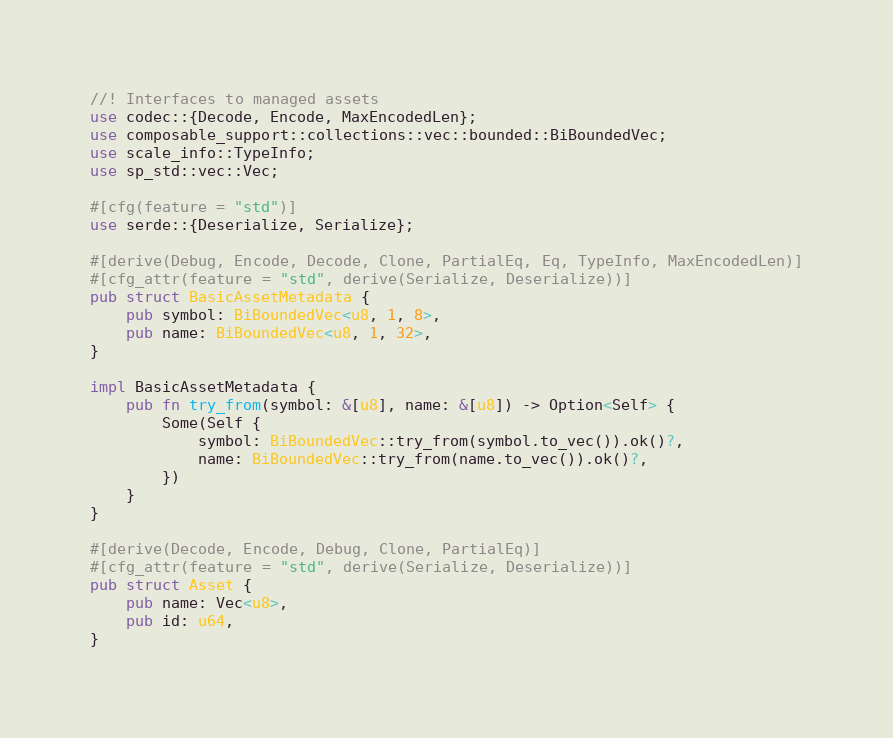Convert code to text. <code><loc_0><loc_0><loc_500><loc_500><_Rust_>//! Interfaces to managed assets
use codec::{Decode, Encode, MaxEncodedLen};
use composable_support::collections::vec::bounded::BiBoundedVec;
use scale_info::TypeInfo;
use sp_std::vec::Vec;

#[cfg(feature = "std")]
use serde::{Deserialize, Serialize};

#[derive(Debug, Encode, Decode, Clone, PartialEq, Eq, TypeInfo, MaxEncodedLen)]
#[cfg_attr(feature = "std", derive(Serialize, Deserialize))]
pub struct BasicAssetMetadata {
	pub symbol: BiBoundedVec<u8, 1, 8>,
	pub name: BiBoundedVec<u8, 1, 32>,
}

impl BasicAssetMetadata {
	pub fn try_from(symbol: &[u8], name: &[u8]) -> Option<Self> {
		Some(Self {
			symbol: BiBoundedVec::try_from(symbol.to_vec()).ok()?,
			name: BiBoundedVec::try_from(name.to_vec()).ok()?,
		})
	}
}

#[derive(Decode, Encode, Debug, Clone, PartialEq)]
#[cfg_attr(feature = "std", derive(Serialize, Deserialize))]
pub struct Asset {
	pub name: Vec<u8>,
	pub id: u64,
}
</code> 